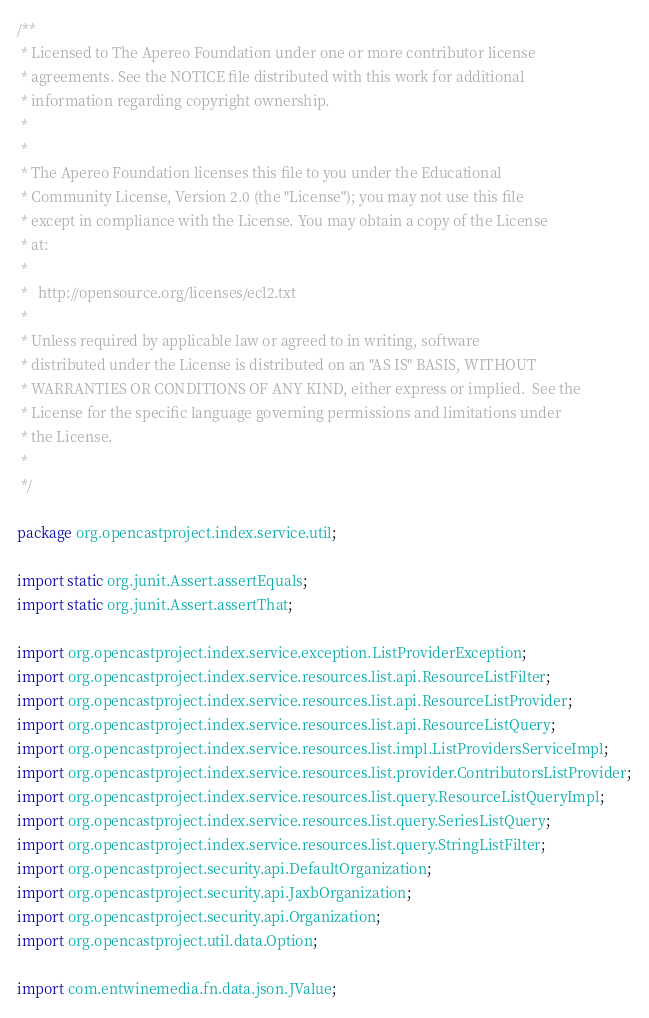Convert code to text. <code><loc_0><loc_0><loc_500><loc_500><_Java_>/**
 * Licensed to The Apereo Foundation under one or more contributor license
 * agreements. See the NOTICE file distributed with this work for additional
 * information regarding copyright ownership.
 *
 *
 * The Apereo Foundation licenses this file to you under the Educational
 * Community License, Version 2.0 (the "License"); you may not use this file
 * except in compliance with the License. You may obtain a copy of the License
 * at:
 *
 *   http://opensource.org/licenses/ecl2.txt
 *
 * Unless required by applicable law or agreed to in writing, software
 * distributed under the License is distributed on an "AS IS" BASIS, WITHOUT
 * WARRANTIES OR CONDITIONS OF ANY KIND, either express or implied.  See the
 * License for the specific language governing permissions and limitations under
 * the License.
 *
 */

package org.opencastproject.index.service.util;

import static org.junit.Assert.assertEquals;
import static org.junit.Assert.assertThat;

import org.opencastproject.index.service.exception.ListProviderException;
import org.opencastproject.index.service.resources.list.api.ResourceListFilter;
import org.opencastproject.index.service.resources.list.api.ResourceListProvider;
import org.opencastproject.index.service.resources.list.api.ResourceListQuery;
import org.opencastproject.index.service.resources.list.impl.ListProvidersServiceImpl;
import org.opencastproject.index.service.resources.list.provider.ContributorsListProvider;
import org.opencastproject.index.service.resources.list.query.ResourceListQueryImpl;
import org.opencastproject.index.service.resources.list.query.SeriesListQuery;
import org.opencastproject.index.service.resources.list.query.StringListFilter;
import org.opencastproject.security.api.DefaultOrganization;
import org.opencastproject.security.api.JaxbOrganization;
import org.opencastproject.security.api.Organization;
import org.opencastproject.util.data.Option;

import com.entwinemedia.fn.data.json.JValue;</code> 